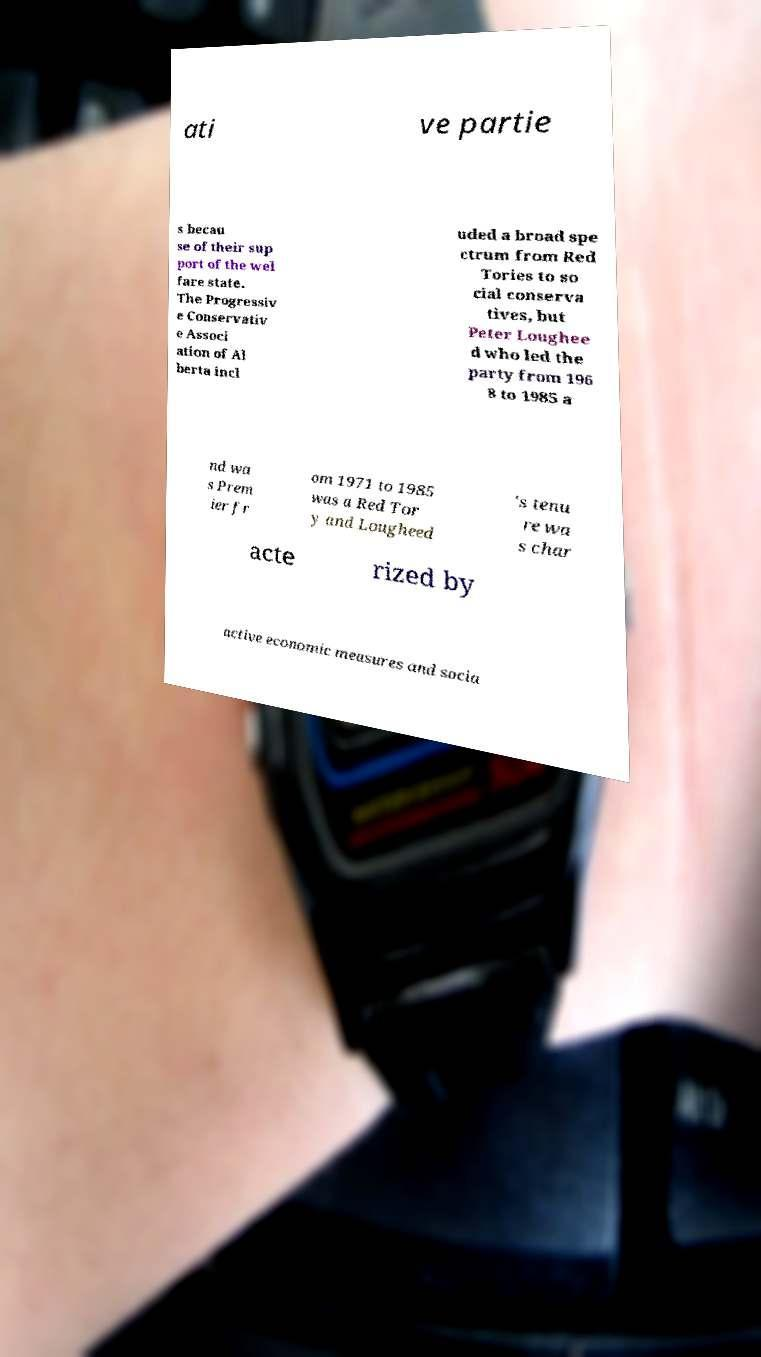What messages or text are displayed in this image? I need them in a readable, typed format. ati ve partie s becau se of their sup port of the wel fare state. The Progressiv e Conservativ e Associ ation of Al berta incl uded a broad spe ctrum from Red Tories to so cial conserva tives, but Peter Loughee d who led the party from 196 8 to 1985 a nd wa s Prem ier fr om 1971 to 1985 was a Red Tor y and Lougheed 's tenu re wa s char acte rized by active economic measures and socia 